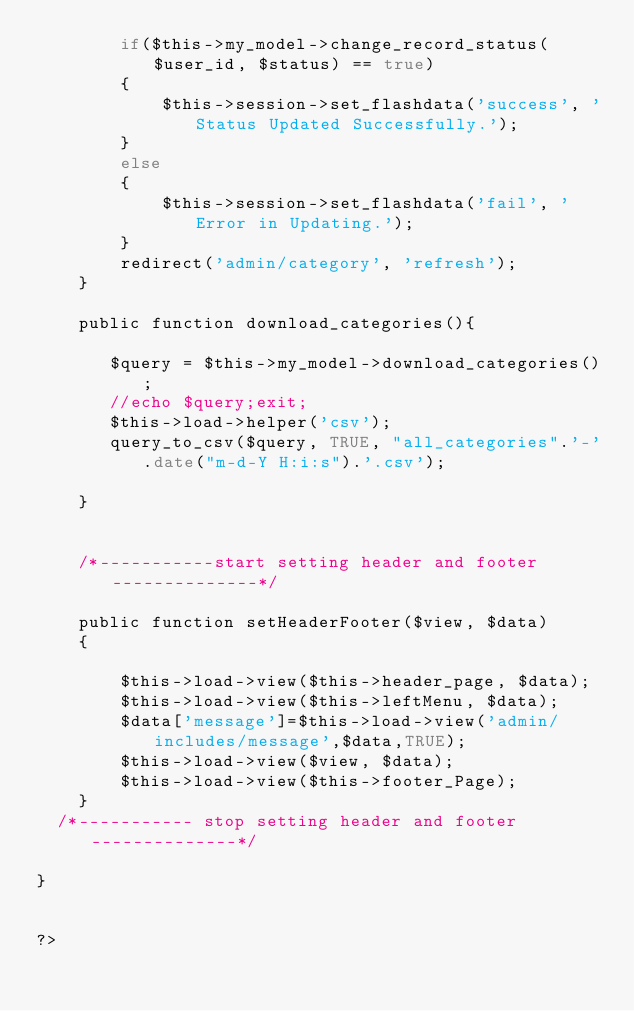<code> <loc_0><loc_0><loc_500><loc_500><_PHP_>		if($this->my_model->change_record_status($user_id, $status) == true)
		{
			$this->session->set_flashdata('success', 'Status Updated Successfully.');
		}
		else
		{
			$this->session->set_flashdata('fail', 'Error in Updating.');
		}
		redirect('admin/category', 'refresh');
	}

	public function download_categories(){

	   $query = $this->my_model->download_categories();
       //echo $query;exit;
       $this->load->helper('csv');
       query_to_csv($query, TRUE, "all_categories".'-'.date("m-d-Y H:i:s").'.csv');

	}


	/*-----------start setting header and footer --------------*/

	public function setHeaderFooter($view, $data)
	{	

		$this->load->view($this->header_page, $data);
		$this->load->view($this->leftMenu, $data);
		$data['message']=$this->load->view('admin/includes/message',$data,TRUE);
		$this->load->view($view, $data);
		$this->load->view($this->footer_Page);
	}
  /*----------- stop setting header and footer --------------*/

}


?></code> 